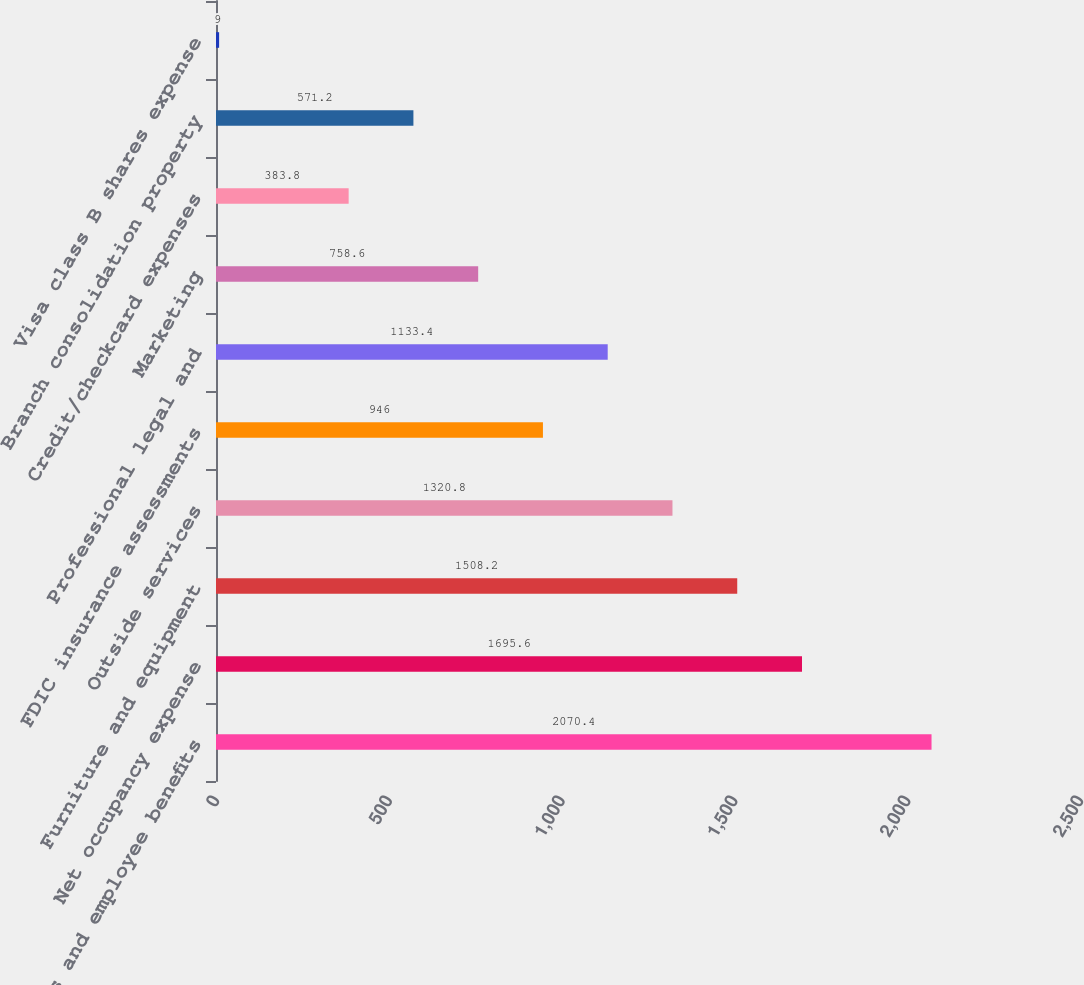Convert chart to OTSL. <chart><loc_0><loc_0><loc_500><loc_500><bar_chart><fcel>Salaries and employee benefits<fcel>Net occupancy expense<fcel>Furniture and equipment<fcel>Outside services<fcel>FDIC insurance assessments<fcel>Professional legal and<fcel>Marketing<fcel>Credit/checkcard expenses<fcel>Branch consolidation property<fcel>Visa class B shares expense<nl><fcel>2070.4<fcel>1695.6<fcel>1508.2<fcel>1320.8<fcel>946<fcel>1133.4<fcel>758.6<fcel>383.8<fcel>571.2<fcel>9<nl></chart> 